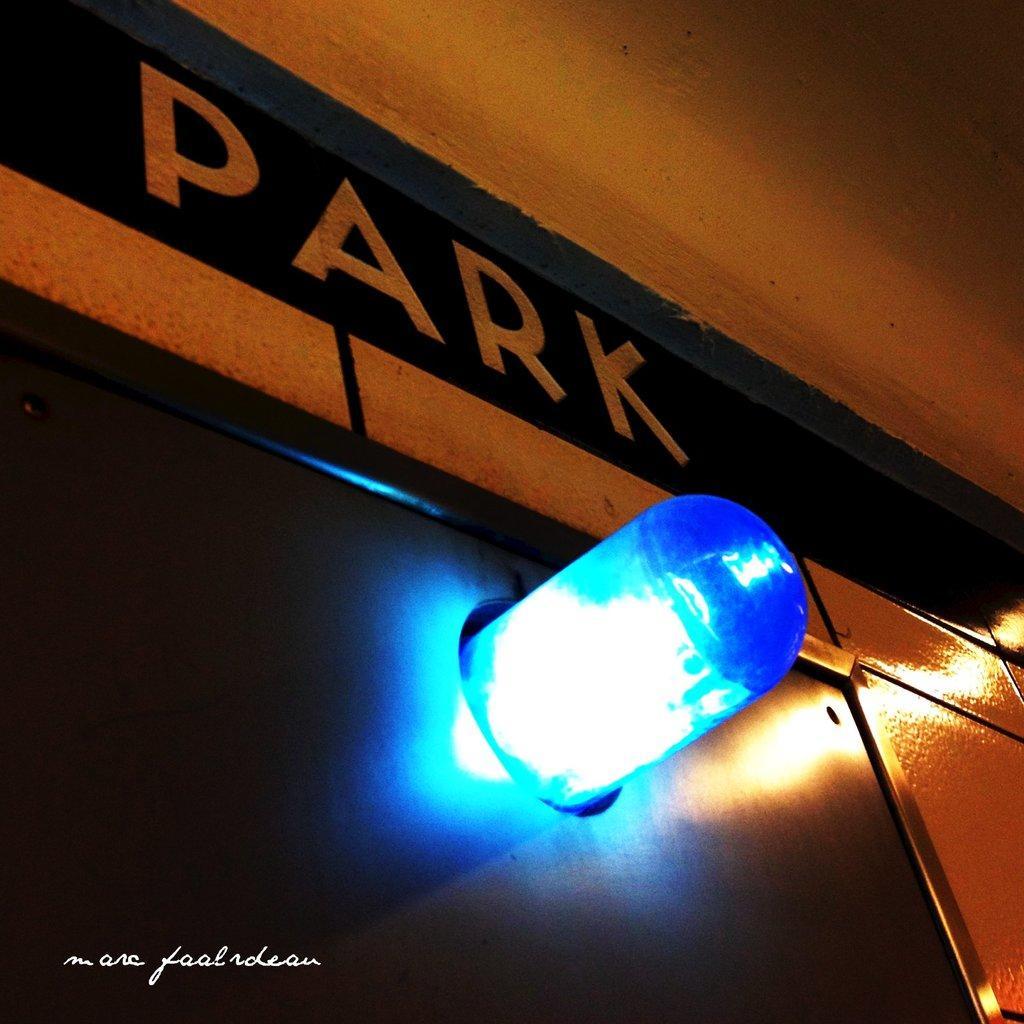Please provide a concise description of this image. There is a blue light and above that ''park'' is written. 